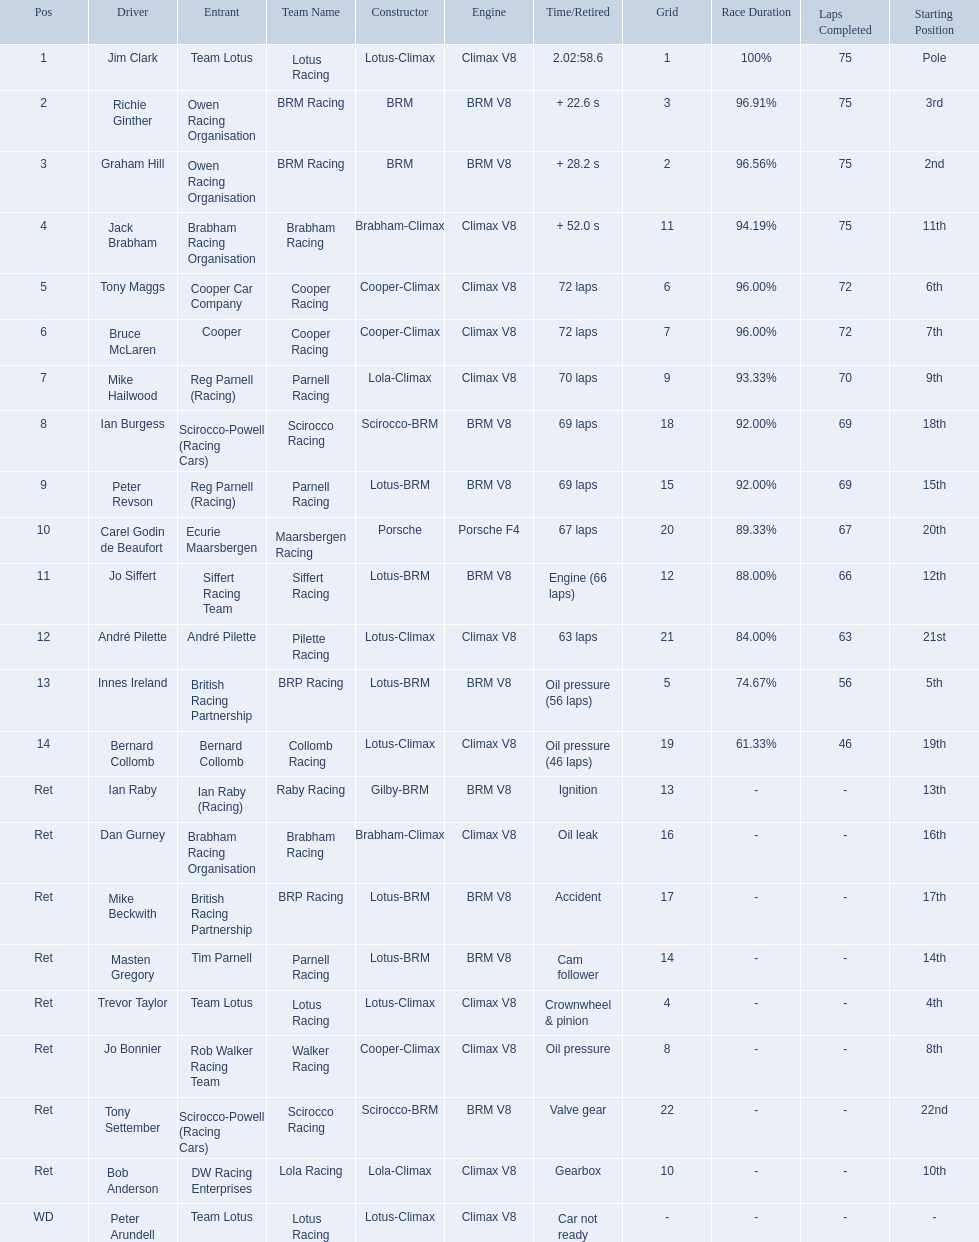What are the listed driver names? Jim Clark, Richie Ginther, Graham Hill, Jack Brabham, Tony Maggs, Bruce McLaren, Mike Hailwood, Ian Burgess, Peter Revson, Carel Godin de Beaufort, Jo Siffert, André Pilette, Innes Ireland, Bernard Collomb, Ian Raby, Dan Gurney, Mike Beckwith, Masten Gregory, Trevor Taylor, Jo Bonnier, Tony Settember, Bob Anderson, Peter Arundell. Which are tony maggs and jo siffert? Tony Maggs, Jo Siffert. What are their corresponding finishing places? 5, 11. Whose is better? Tony Maggs. 